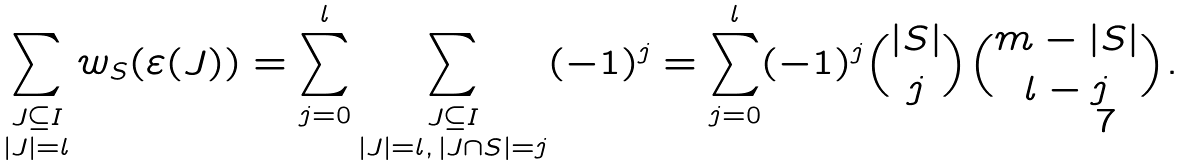<formula> <loc_0><loc_0><loc_500><loc_500>\sum _ { \substack { J \subseteq I \\ | J | = l } } w _ { S } ( \varepsilon ( J ) ) = \sum _ { j = 0 } ^ { l } \sum _ { \substack { J \subseteq I \\ | J | = l , \, | J \cap S | = j } } ( - 1 ) ^ { j } = \sum _ { j = 0 } ^ { l } ( - 1 ) ^ { j } \binom { | S | } { j } \binom { m - | S | } { l - j } .</formula> 